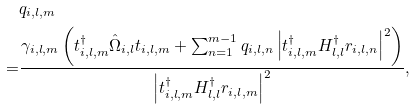<formula> <loc_0><loc_0><loc_500><loc_500>& q _ { i , l , m } \\ = & \frac { \gamma _ { i , l , m } \left ( t _ { i , l , m } ^ { \dagger } \hat { \Omega } _ { i , l } t _ { i , l , m } + \sum _ { n = 1 } ^ { m - 1 } q _ { i , l , n } \left | t _ { i , l , m } ^ { \dagger } H _ { l , l } ^ { \dagger } r _ { i , l , n } \right | ^ { 2 } \right ) } { \left | t _ { i , l , m } ^ { \dagger } H _ { l , l } ^ { \dagger } r _ { i , l , m } \right | ^ { 2 } } ,</formula> 